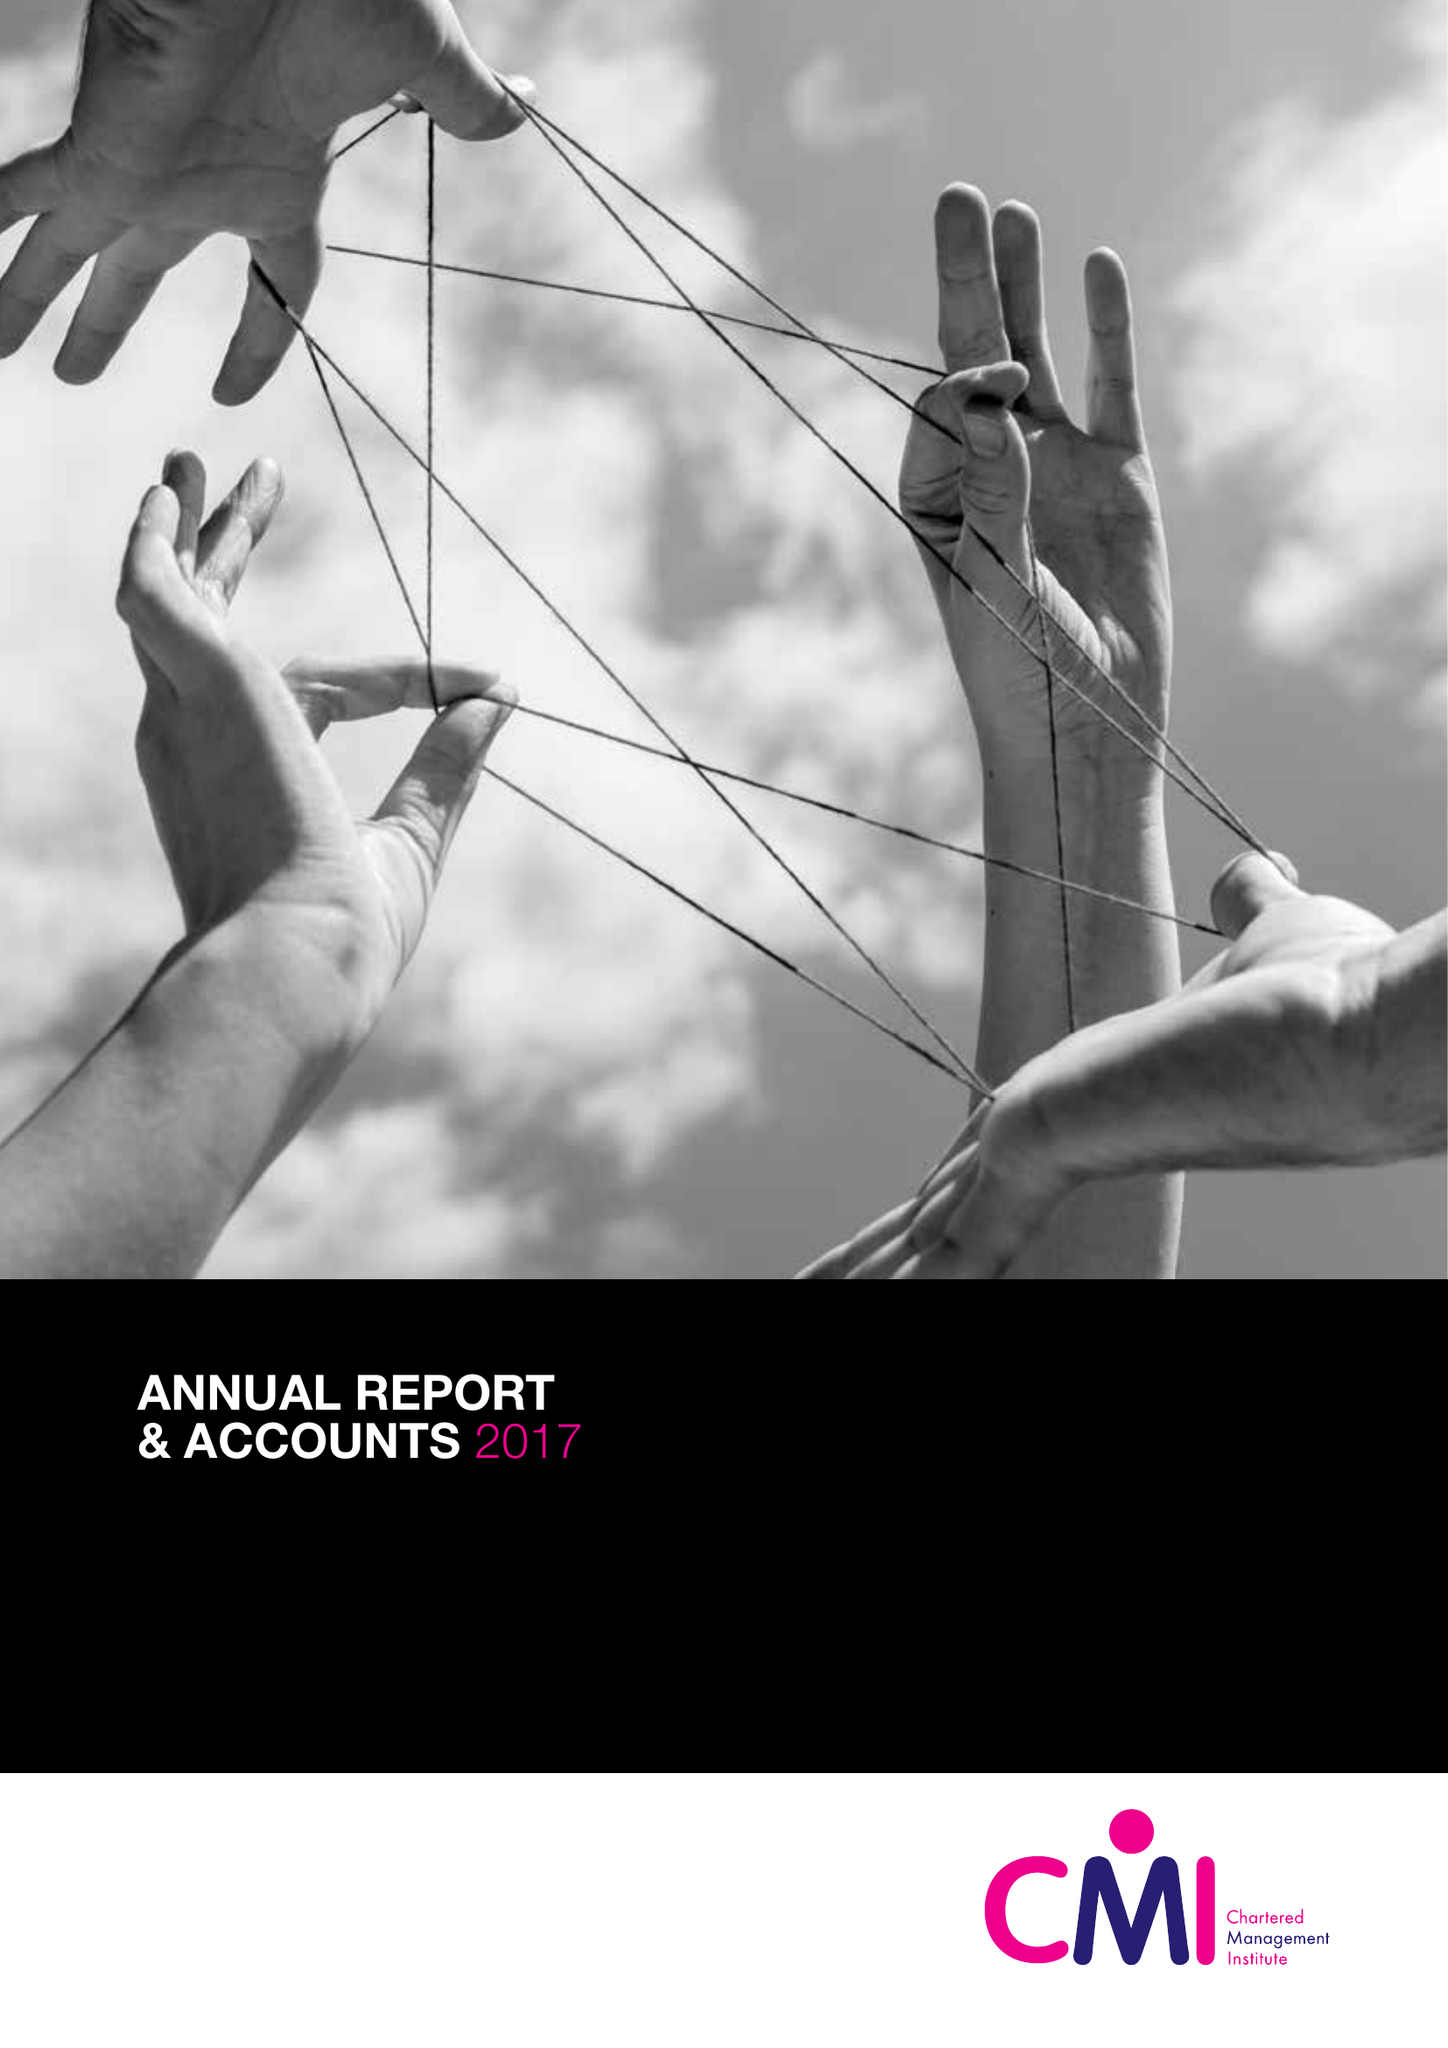What is the value for the address__postcode?
Answer the question using a single word or phrase. NN17 1TT 